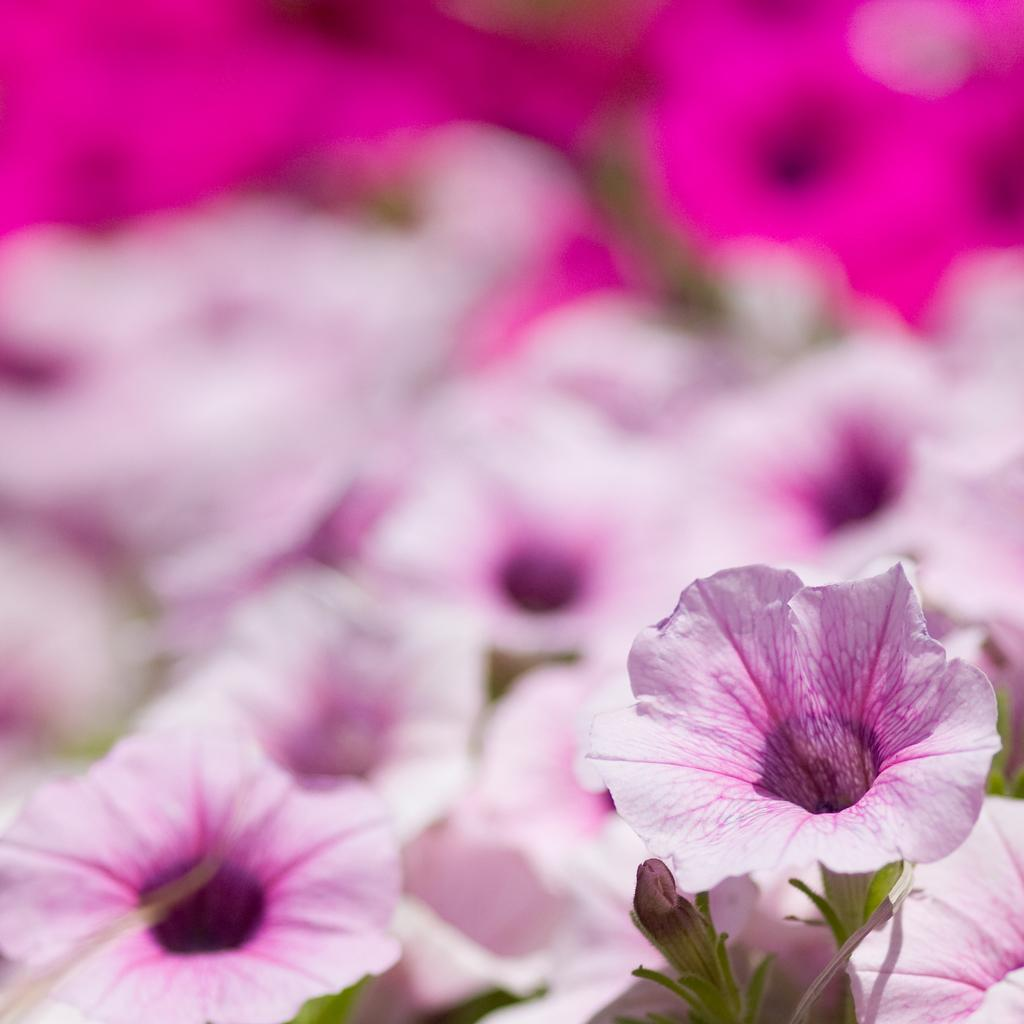What type of flowers can be seen in the image? There are pink color flowers in the image. Can you describe the background of the image? The background of the image is blurred. How many feet are visible in the image? There are no feet visible in the image; it only features pink color flowers and a blurred background. 